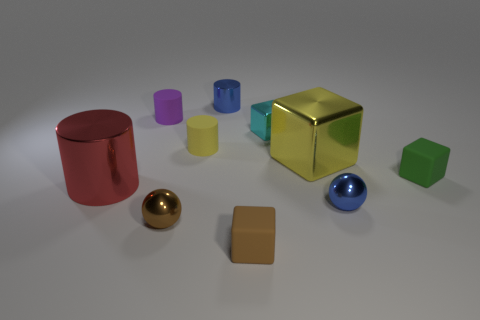The brown object that is made of the same material as the green object is what shape?
Make the answer very short. Cube. How many metal cylinders are behind the big yellow metal thing?
Give a very brief answer. 1. Are there an equal number of large red metallic objects that are to the left of the red metal thing and gray blocks?
Offer a terse response. Yes. Does the big red cylinder have the same material as the small green object?
Provide a succinct answer. No. How big is the metal thing that is both to the left of the blue cylinder and behind the blue ball?
Keep it short and to the point. Large. How many brown cylinders are the same size as the green matte thing?
Provide a succinct answer. 0. What size is the ball that is left of the small cylinder that is in front of the tiny cyan block?
Keep it short and to the point. Small. Does the small object that is behind the purple object have the same shape as the large metallic thing that is to the left of the purple rubber cylinder?
Keep it short and to the point. Yes. What color is the small cube that is on the left side of the green matte object and behind the brown cube?
Your response must be concise. Cyan. Is there a matte thing that has the same color as the big metallic block?
Offer a very short reply. Yes. 